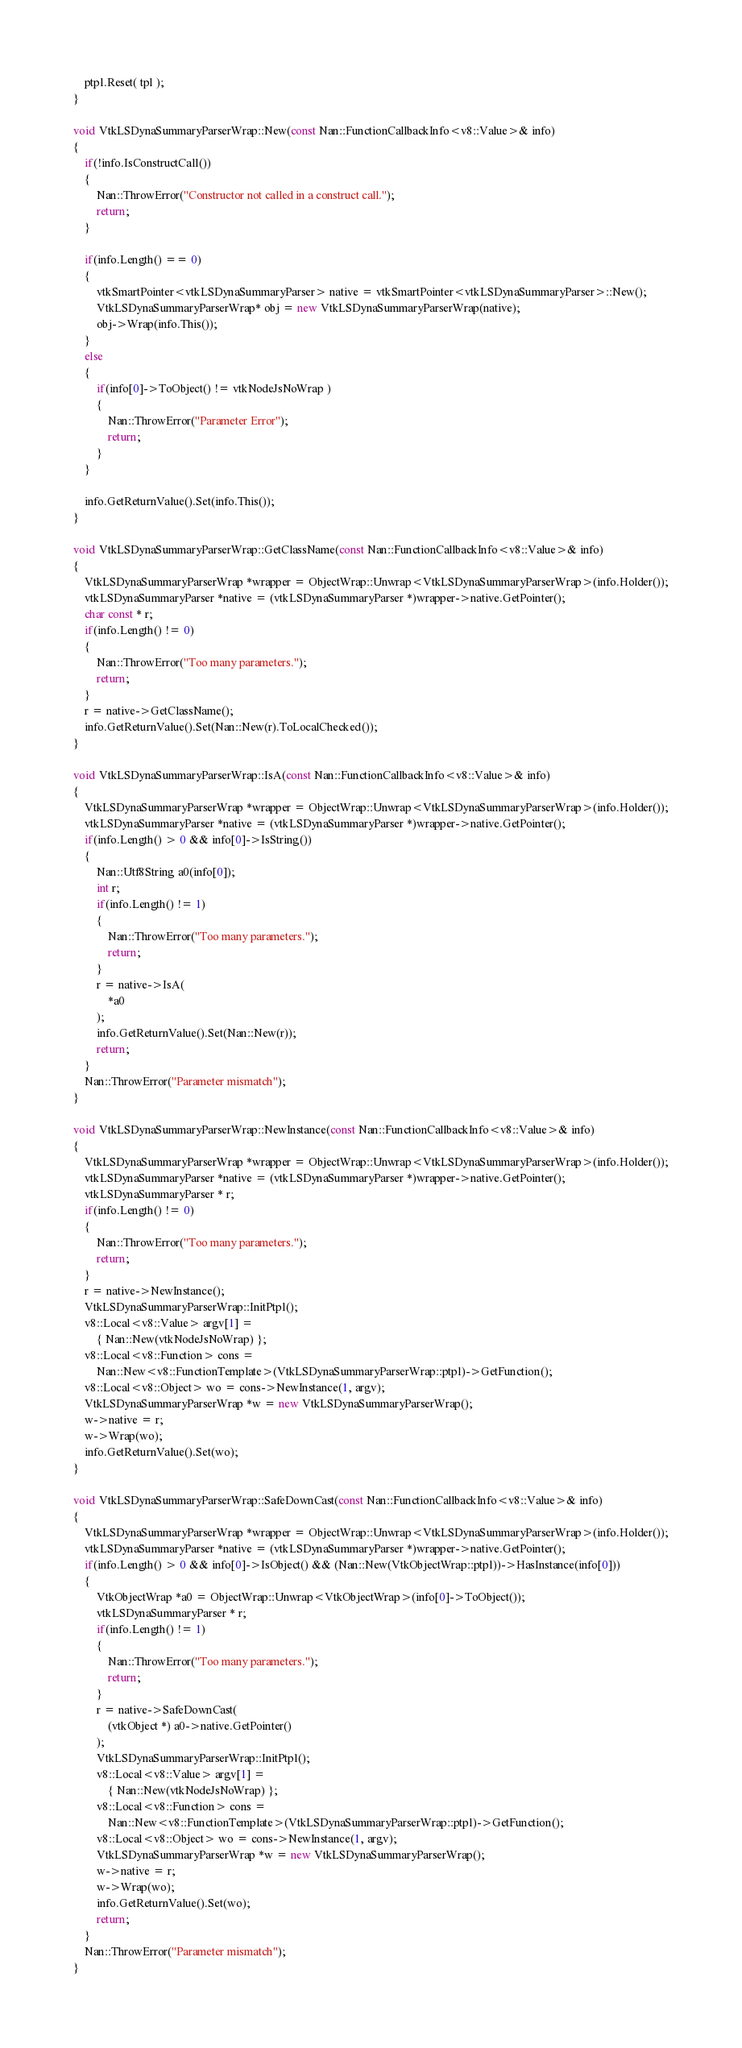Convert code to text. <code><loc_0><loc_0><loc_500><loc_500><_C++_>	ptpl.Reset( tpl );
}

void VtkLSDynaSummaryParserWrap::New(const Nan::FunctionCallbackInfo<v8::Value>& info)
{
	if(!info.IsConstructCall())
	{
		Nan::ThrowError("Constructor not called in a construct call.");
		return;
	}

	if(info.Length() == 0)
	{
		vtkSmartPointer<vtkLSDynaSummaryParser> native = vtkSmartPointer<vtkLSDynaSummaryParser>::New();
		VtkLSDynaSummaryParserWrap* obj = new VtkLSDynaSummaryParserWrap(native);
		obj->Wrap(info.This());
	}
	else
	{
		if(info[0]->ToObject() != vtkNodeJsNoWrap )
		{
			Nan::ThrowError("Parameter Error");
			return;
		}
	}

	info.GetReturnValue().Set(info.This());
}

void VtkLSDynaSummaryParserWrap::GetClassName(const Nan::FunctionCallbackInfo<v8::Value>& info)
{
	VtkLSDynaSummaryParserWrap *wrapper = ObjectWrap::Unwrap<VtkLSDynaSummaryParserWrap>(info.Holder());
	vtkLSDynaSummaryParser *native = (vtkLSDynaSummaryParser *)wrapper->native.GetPointer();
	char const * r;
	if(info.Length() != 0)
	{
		Nan::ThrowError("Too many parameters.");
		return;
	}
	r = native->GetClassName();
	info.GetReturnValue().Set(Nan::New(r).ToLocalChecked());
}

void VtkLSDynaSummaryParserWrap::IsA(const Nan::FunctionCallbackInfo<v8::Value>& info)
{
	VtkLSDynaSummaryParserWrap *wrapper = ObjectWrap::Unwrap<VtkLSDynaSummaryParserWrap>(info.Holder());
	vtkLSDynaSummaryParser *native = (vtkLSDynaSummaryParser *)wrapper->native.GetPointer();
	if(info.Length() > 0 && info[0]->IsString())
	{
		Nan::Utf8String a0(info[0]);
		int r;
		if(info.Length() != 1)
		{
			Nan::ThrowError("Too many parameters.");
			return;
		}
		r = native->IsA(
			*a0
		);
		info.GetReturnValue().Set(Nan::New(r));
		return;
	}
	Nan::ThrowError("Parameter mismatch");
}

void VtkLSDynaSummaryParserWrap::NewInstance(const Nan::FunctionCallbackInfo<v8::Value>& info)
{
	VtkLSDynaSummaryParserWrap *wrapper = ObjectWrap::Unwrap<VtkLSDynaSummaryParserWrap>(info.Holder());
	vtkLSDynaSummaryParser *native = (vtkLSDynaSummaryParser *)wrapper->native.GetPointer();
	vtkLSDynaSummaryParser * r;
	if(info.Length() != 0)
	{
		Nan::ThrowError("Too many parameters.");
		return;
	}
	r = native->NewInstance();
	VtkLSDynaSummaryParserWrap::InitPtpl();
	v8::Local<v8::Value> argv[1] =
		{ Nan::New(vtkNodeJsNoWrap) };
	v8::Local<v8::Function> cons =
		Nan::New<v8::FunctionTemplate>(VtkLSDynaSummaryParserWrap::ptpl)->GetFunction();
	v8::Local<v8::Object> wo = cons->NewInstance(1, argv);
	VtkLSDynaSummaryParserWrap *w = new VtkLSDynaSummaryParserWrap();
	w->native = r;
	w->Wrap(wo);
	info.GetReturnValue().Set(wo);
}

void VtkLSDynaSummaryParserWrap::SafeDownCast(const Nan::FunctionCallbackInfo<v8::Value>& info)
{
	VtkLSDynaSummaryParserWrap *wrapper = ObjectWrap::Unwrap<VtkLSDynaSummaryParserWrap>(info.Holder());
	vtkLSDynaSummaryParser *native = (vtkLSDynaSummaryParser *)wrapper->native.GetPointer();
	if(info.Length() > 0 && info[0]->IsObject() && (Nan::New(VtkObjectWrap::ptpl))->HasInstance(info[0]))
	{
		VtkObjectWrap *a0 = ObjectWrap::Unwrap<VtkObjectWrap>(info[0]->ToObject());
		vtkLSDynaSummaryParser * r;
		if(info.Length() != 1)
		{
			Nan::ThrowError("Too many parameters.");
			return;
		}
		r = native->SafeDownCast(
			(vtkObject *) a0->native.GetPointer()
		);
		VtkLSDynaSummaryParserWrap::InitPtpl();
		v8::Local<v8::Value> argv[1] =
			{ Nan::New(vtkNodeJsNoWrap) };
		v8::Local<v8::Function> cons =
			Nan::New<v8::FunctionTemplate>(VtkLSDynaSummaryParserWrap::ptpl)->GetFunction();
		v8::Local<v8::Object> wo = cons->NewInstance(1, argv);
		VtkLSDynaSummaryParserWrap *w = new VtkLSDynaSummaryParserWrap();
		w->native = r;
		w->Wrap(wo);
		info.GetReturnValue().Set(wo);
		return;
	}
	Nan::ThrowError("Parameter mismatch");
}

</code> 